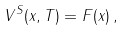Convert formula to latex. <formula><loc_0><loc_0><loc_500><loc_500>V ^ { S } ( x , T ) = F ( x ) \, ,</formula> 